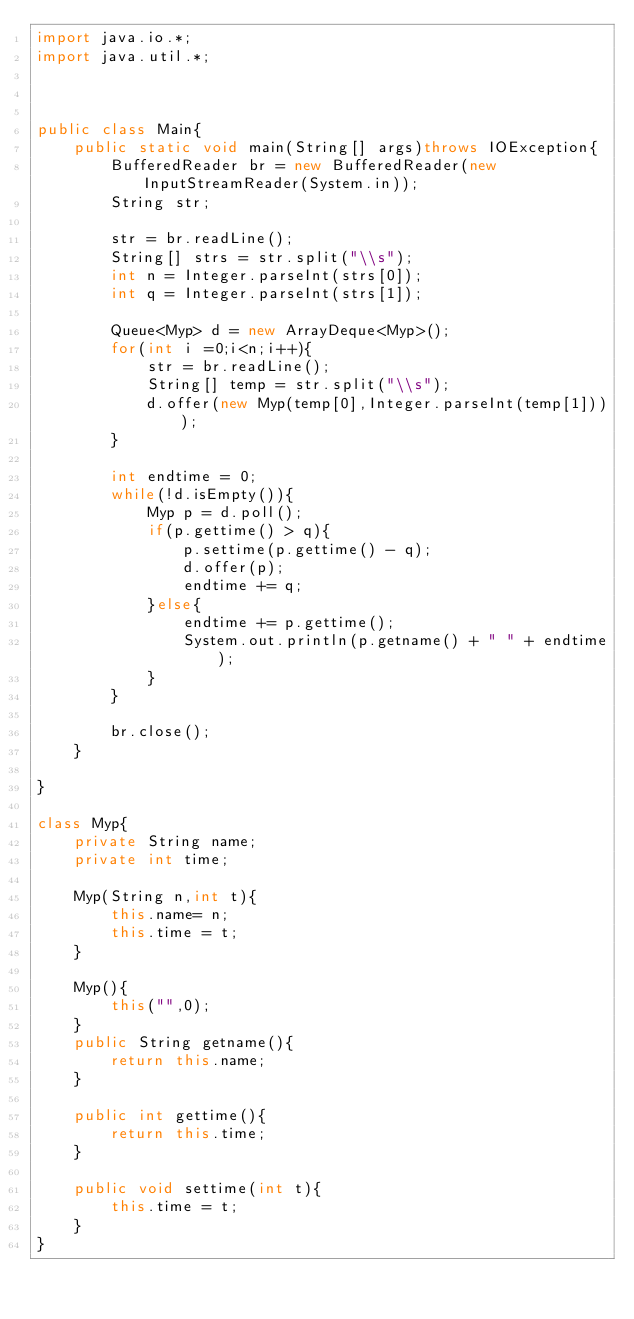Convert code to text. <code><loc_0><loc_0><loc_500><loc_500><_Java_>import java.io.*;
import java.util.*;



public class Main{
    public static void main(String[] args)throws IOException{
        BufferedReader br = new BufferedReader(new InputStreamReader(System.in));
        String str;

        str = br.readLine();
        String[] strs = str.split("\\s");
        int n = Integer.parseInt(strs[0]);
        int q = Integer.parseInt(strs[1]);

        Queue<Myp> d = new ArrayDeque<Myp>();
        for(int i =0;i<n;i++){
            str = br.readLine();
            String[] temp = str.split("\\s");
            d.offer(new Myp(temp[0],Integer.parseInt(temp[1])));
        }
        
        int endtime = 0;
        while(!d.isEmpty()){
            Myp p = d.poll();
            if(p.gettime() > q){
                p.settime(p.gettime() - q);
                d.offer(p);
                endtime += q;
            }else{
                endtime += p.gettime();
                System.out.println(p.getname() + " " + endtime);
            }
        }

        br.close();
    }
   
}

class Myp{
    private String name;
    private int time;
    
    Myp(String n,int t){
        this.name= n;
        this.time = t;
    }

    Myp(){
        this("",0);
    }
    public String getname(){
        return this.name;
    }

    public int gettime(){
        return this.time;
    }

    public void settime(int t){
        this.time = t;
    }
}
</code> 